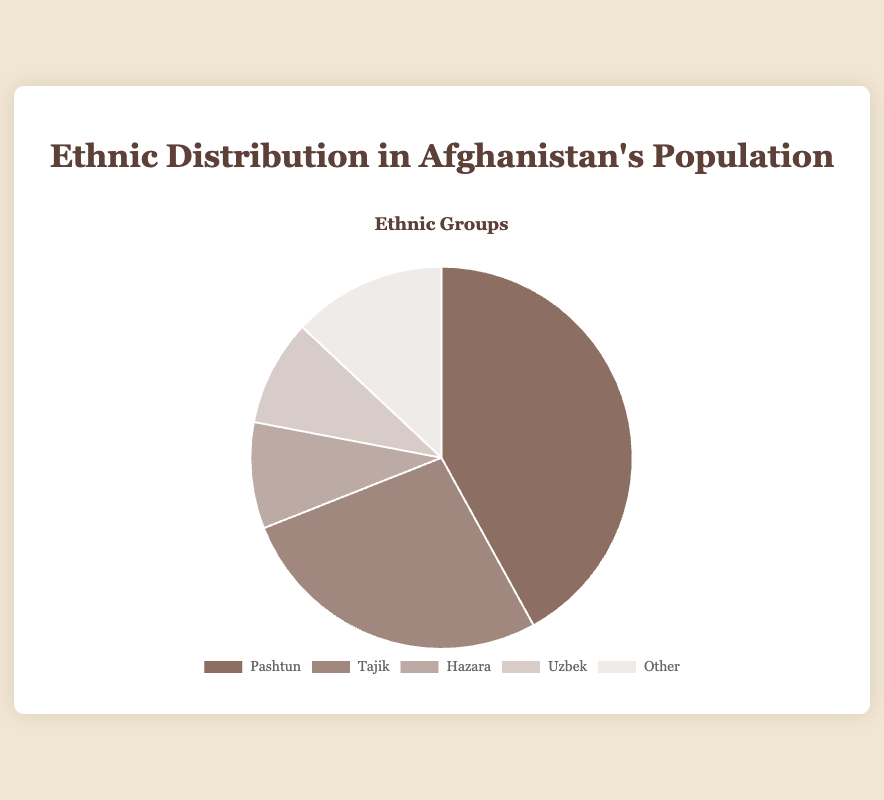What is the most populous ethnic group in Afghanistan according to the chart? To determine the most populous ethnic group, we look at the percentages given to each group in the pie chart. The Pashtun group has the highest percentage at 42%.
Answer: Pashtun Which two ethnic groups have the same percentage in the population? We observe the percentages provided for each ethnic group. Both the Hazara and Uzbek groups each have a percentage of 9%.
Answer: Hazara and Uzbek What is the combined percentage of the Hazara and Uzbek groups? Adding the percentages of the Hazara and Uzbek ethnic groups: 9% + 9%, the combined percentage is 18%.
Answer: 18% How much more is the Pashtun population compared to the Tajik population? Subtract the percentage of the Tajik group from the Pashtun group: 42% - 27%. The difference is 15%.
Answer: 15% Which ethnic group has the lowest representation? By examining the given percentages, the Hazara and Uzbek groups both have the lowest representation at 9%.
Answer: Hazara and Uzbek What is the combined percentage of the Tajik and 'Other' groups? Sum the percentages of the Tajik and 'Other' groups: 27% + 13%. The combined percentage is 40%.
Answer: 40% How does the Hazara group's percentage compare to the 'Other' group's percentage? By comparing the percentages, the Hazara group has 9% while the 'Other' group has 13%. Hence, the 'Other' group has a larger percentage.
Answer: 'Other' group is larger by 4% What is the total percentage of all groups combined? Summing up the percentages of all groups: 42% (Pashtun) + 27% (Tajik) + 9% (Hazara) + 9% (Uzbek) + 13% (Other): 100%.
Answer: 100% Among the given ethnic groups, how many have a percentage lower than 10%? By looking at the percentages provided, both the Hazara and Uzbek groups have a percentage of 9%, which is less than 10%. Therefore, two groups have percentages lower than 10%.
Answer: Two What percentage of the population is composed of groups other than Pashtun and Tajik? Subtract the combined percentage of Pashtun and Tajik groups from 100%: 100% - (42% + 27%) = 31%. Therefore, 31% of the population is composed of groups other than Pashtun and Tajik.
Answer: 31% 